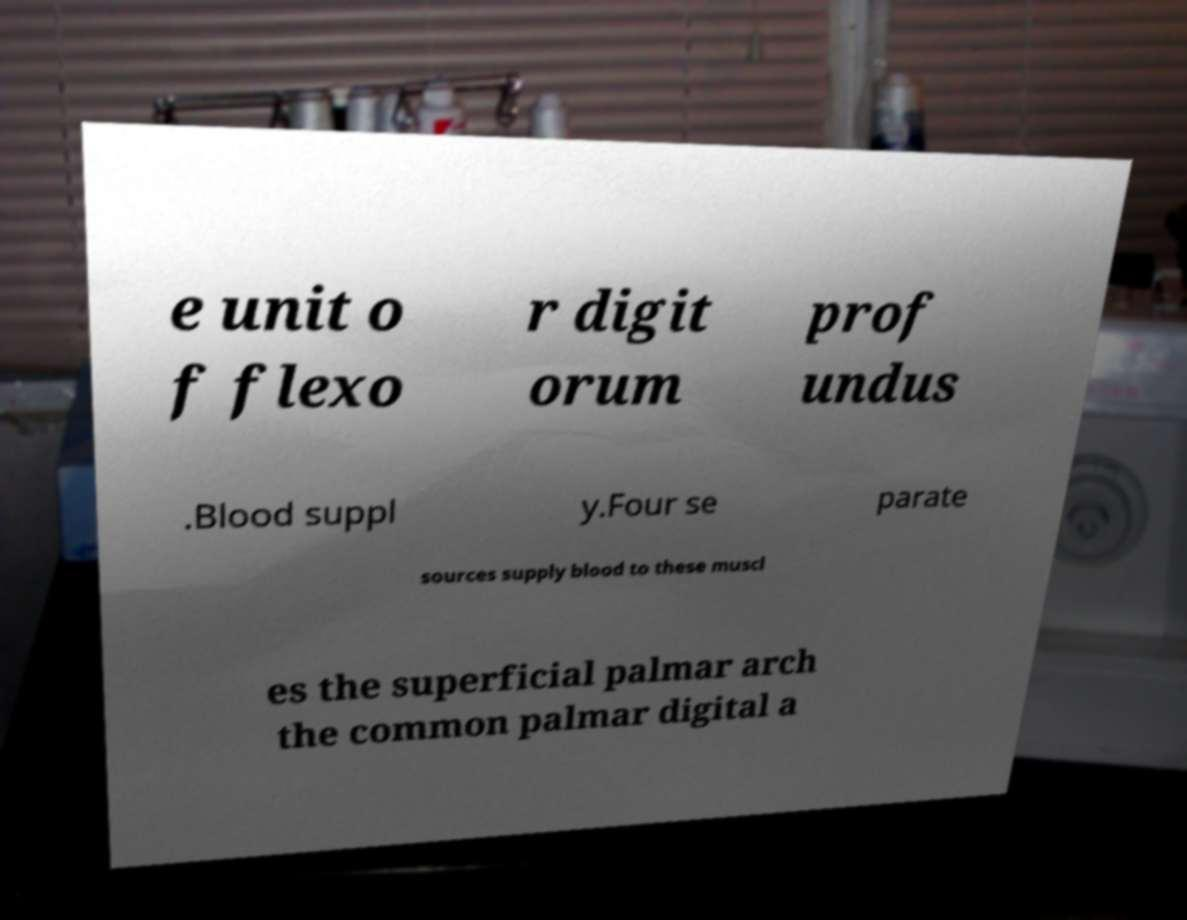For documentation purposes, I need the text within this image transcribed. Could you provide that? e unit o f flexo r digit orum prof undus .Blood suppl y.Four se parate sources supply blood to these muscl es the superficial palmar arch the common palmar digital a 